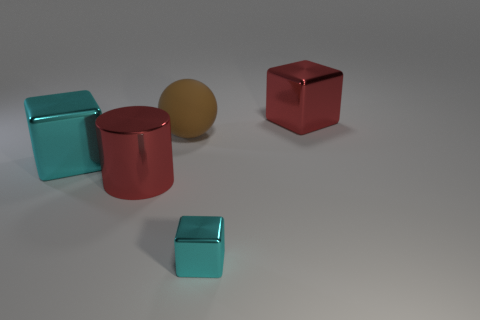What shape is the cyan shiny object that is the same size as the metal cylinder?
Provide a short and direct response. Cube. Are there the same number of red metal things in front of the brown matte object and big red blocks that are left of the tiny metal thing?
Offer a very short reply. No. There is a cyan shiny thing in front of the red shiny object in front of the big cyan shiny thing; what size is it?
Offer a very short reply. Small. Is there a red cube of the same size as the matte ball?
Your answer should be very brief. Yes. What color is the cylinder that is the same material as the red block?
Your answer should be compact. Red. Are there fewer large matte spheres than metallic objects?
Keep it short and to the point. Yes. There is a large object that is both behind the large cyan block and to the left of the small block; what material is it made of?
Make the answer very short. Rubber. There is a big red metal thing in front of the large cyan shiny block; is there a large object that is behind it?
Give a very brief answer. Yes. What number of things are the same color as the large matte ball?
Your answer should be very brief. 0. What material is the big thing that is the same color as the big cylinder?
Make the answer very short. Metal. 